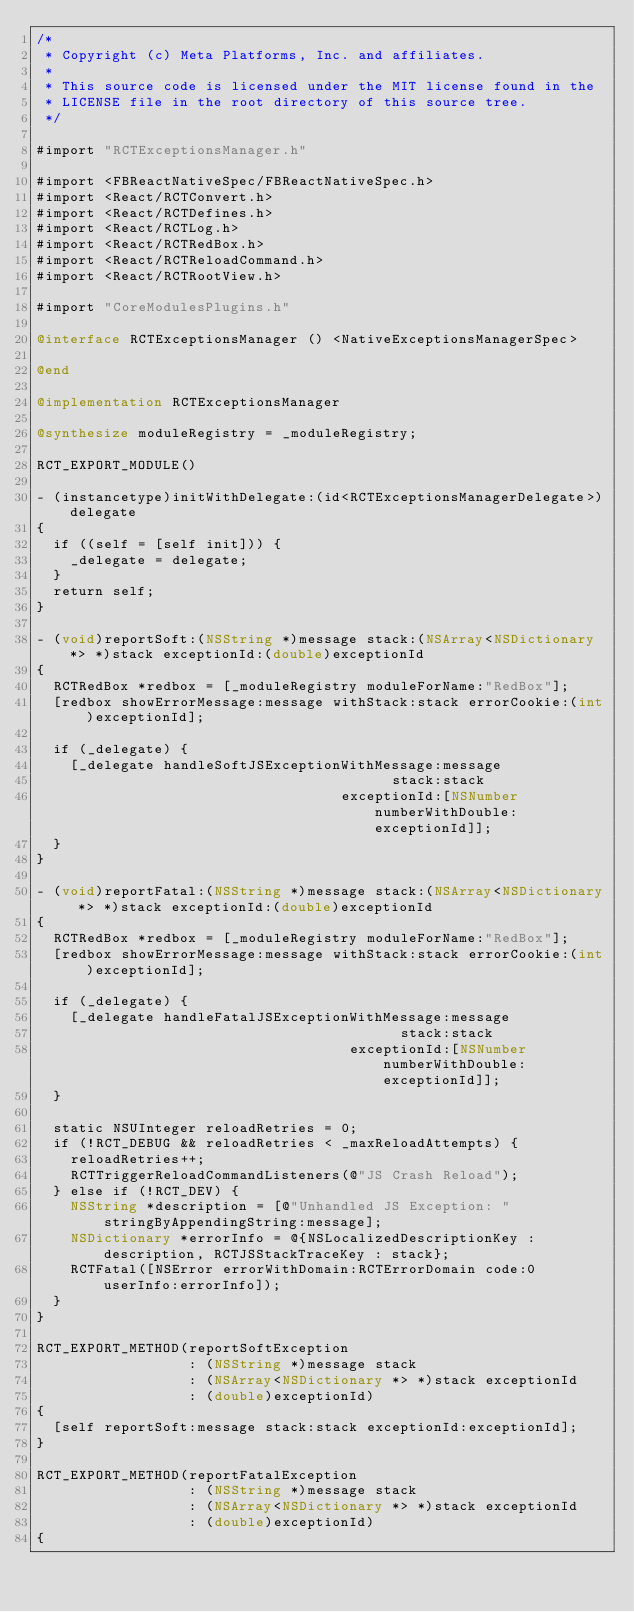<code> <loc_0><loc_0><loc_500><loc_500><_ObjectiveC_>/*
 * Copyright (c) Meta Platforms, Inc. and affiliates.
 *
 * This source code is licensed under the MIT license found in the
 * LICENSE file in the root directory of this source tree.
 */

#import "RCTExceptionsManager.h"

#import <FBReactNativeSpec/FBReactNativeSpec.h>
#import <React/RCTConvert.h>
#import <React/RCTDefines.h>
#import <React/RCTLog.h>
#import <React/RCTRedBox.h>
#import <React/RCTReloadCommand.h>
#import <React/RCTRootView.h>

#import "CoreModulesPlugins.h"

@interface RCTExceptionsManager () <NativeExceptionsManagerSpec>

@end

@implementation RCTExceptionsManager

@synthesize moduleRegistry = _moduleRegistry;

RCT_EXPORT_MODULE()

- (instancetype)initWithDelegate:(id<RCTExceptionsManagerDelegate>)delegate
{
  if ((self = [self init])) {
    _delegate = delegate;
  }
  return self;
}

- (void)reportSoft:(NSString *)message stack:(NSArray<NSDictionary *> *)stack exceptionId:(double)exceptionId
{
  RCTRedBox *redbox = [_moduleRegistry moduleForName:"RedBox"];
  [redbox showErrorMessage:message withStack:stack errorCookie:(int)exceptionId];

  if (_delegate) {
    [_delegate handleSoftJSExceptionWithMessage:message
                                          stack:stack
                                    exceptionId:[NSNumber numberWithDouble:exceptionId]];
  }
}

- (void)reportFatal:(NSString *)message stack:(NSArray<NSDictionary *> *)stack exceptionId:(double)exceptionId
{
  RCTRedBox *redbox = [_moduleRegistry moduleForName:"RedBox"];
  [redbox showErrorMessage:message withStack:stack errorCookie:(int)exceptionId];

  if (_delegate) {
    [_delegate handleFatalJSExceptionWithMessage:message
                                           stack:stack
                                     exceptionId:[NSNumber numberWithDouble:exceptionId]];
  }

  static NSUInteger reloadRetries = 0;
  if (!RCT_DEBUG && reloadRetries < _maxReloadAttempts) {
    reloadRetries++;
    RCTTriggerReloadCommandListeners(@"JS Crash Reload");
  } else if (!RCT_DEV) {
    NSString *description = [@"Unhandled JS Exception: " stringByAppendingString:message];
    NSDictionary *errorInfo = @{NSLocalizedDescriptionKey : description, RCTJSStackTraceKey : stack};
    RCTFatal([NSError errorWithDomain:RCTErrorDomain code:0 userInfo:errorInfo]);
  }
}

RCT_EXPORT_METHOD(reportSoftException
                  : (NSString *)message stack
                  : (NSArray<NSDictionary *> *)stack exceptionId
                  : (double)exceptionId)
{
  [self reportSoft:message stack:stack exceptionId:exceptionId];
}

RCT_EXPORT_METHOD(reportFatalException
                  : (NSString *)message stack
                  : (NSArray<NSDictionary *> *)stack exceptionId
                  : (double)exceptionId)
{</code> 